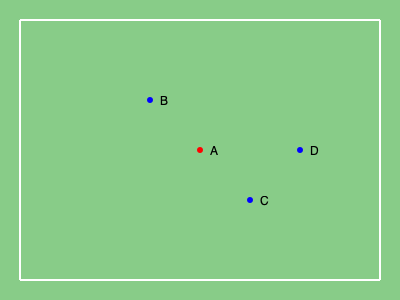In the diagram above, player A (red) from the attacking team is positioned between three defenders B, C, and D (blue) from the opposing team. Calculate the x-coordinate of the offside line, given that the goal line is at x = 400 and the coordinates of the defenders are B(150, 100), C(250, 200), and D(300, 150). Round your answer to the nearest whole number. To determine the offside line position, we need to follow these steps:

1) The offside line is determined by the position of the second-last defender (including the goalkeeper). In this case, we need to find the defender closest to their own goal line, excluding the goalkeeper.

2) The x-coordinates of the defenders are:
   B: x = 150
   C: x = 250
   D: x = 300

3) We need to identify the two defenders closest to their own goal line (x = 400).

4) Ordering the defenders from closest to farthest from their goal line:
   D (300), C (250), B (150)

5) The second-last defender is C, with an x-coordinate of 250.

6) Therefore, the offside line is positioned at x = 250.

7) No rounding is necessary as the coordinate is already a whole number.
Answer: 250 